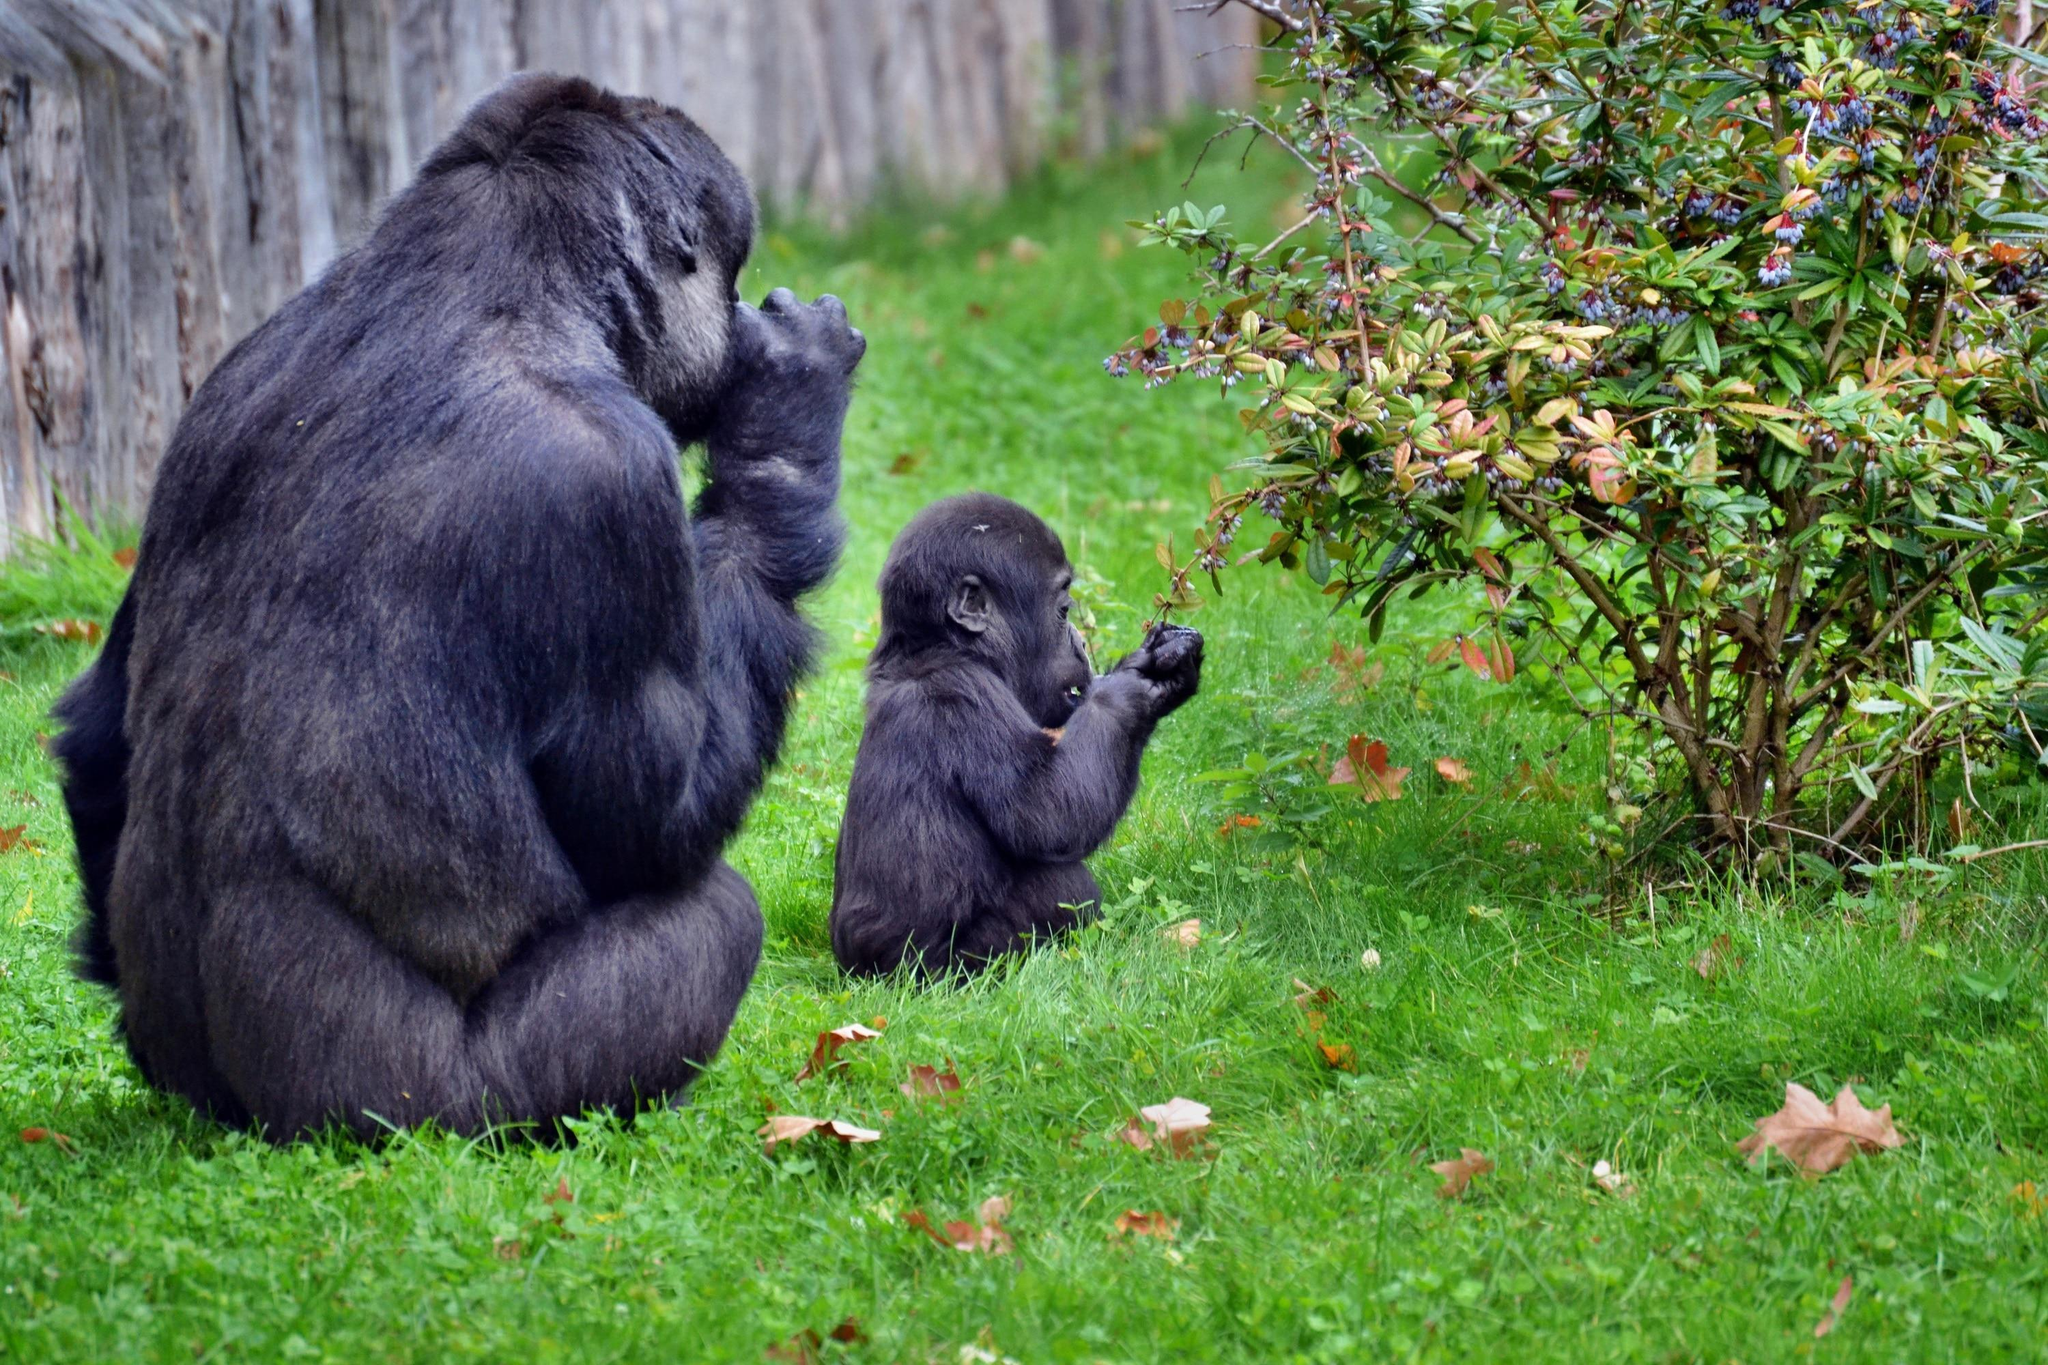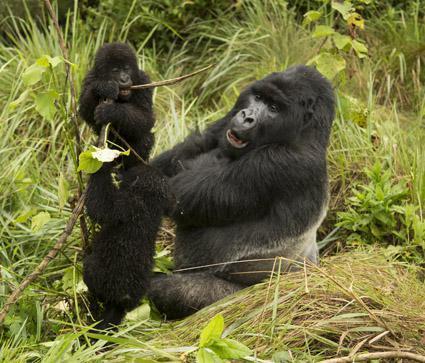The first image is the image on the left, the second image is the image on the right. For the images displayed, is the sentence "An image containing exactly two gorillas includes a male gorilla on all fours moving toward the camera." factually correct? Answer yes or no. No. The first image is the image on the left, the second image is the image on the right. Considering the images on both sides, is "There are exactly five gorillas." valid? Answer yes or no. Yes. 